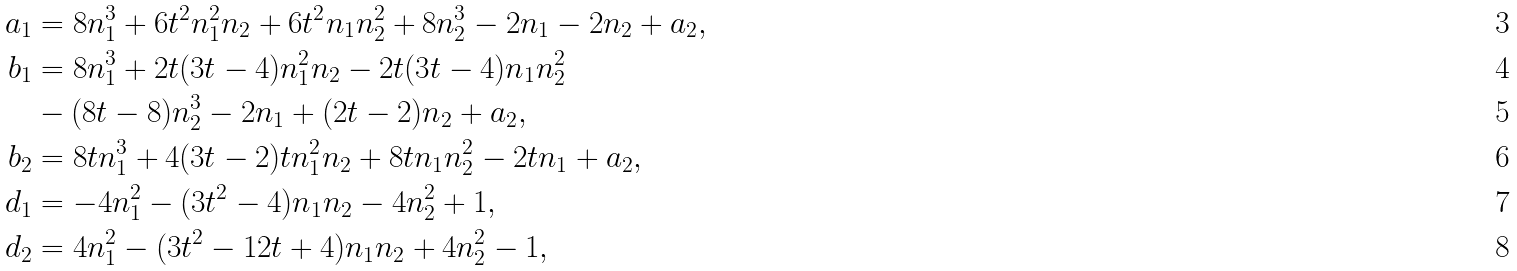Convert formula to latex. <formula><loc_0><loc_0><loc_500><loc_500>a _ { 1 } & = 8 n _ { 1 } ^ { 3 } + 6 t ^ { 2 } n _ { 1 } ^ { 2 } n _ { 2 } + 6 t ^ { 2 } n _ { 1 } n _ { 2 } ^ { 2 } + 8 n _ { 2 } ^ { 3 } - 2 n _ { 1 } - 2 n _ { 2 } + a _ { 2 } , \\ b _ { 1 } & = 8 n _ { 1 } ^ { 3 } + 2 t ( 3 t - 4 ) n _ { 1 } ^ { 2 } n _ { 2 } - 2 t ( 3 t - 4 ) n _ { 1 } n _ { 2 } ^ { 2 } \\ & - ( 8 t - 8 ) n _ { 2 } ^ { 3 } - 2 n _ { 1 } + ( 2 t - 2 ) n _ { 2 } + a _ { 2 } , \\ b _ { 2 } & = 8 t n _ { 1 } ^ { 3 } + 4 ( 3 t - 2 ) t n _ { 1 } ^ { 2 } n _ { 2 } + 8 t n _ { 1 } n _ { 2 } ^ { 2 } - 2 t n _ { 1 } + a _ { 2 } , \\ d _ { 1 } & = - 4 n _ { 1 } ^ { 2 } - ( 3 t ^ { 2 } - 4 ) n _ { 1 } n _ { 2 } - 4 n _ { 2 } ^ { 2 } + 1 , \\ d _ { 2 } & = 4 n _ { 1 } ^ { 2 } - ( 3 t ^ { 2 } - 1 2 t + 4 ) n _ { 1 } n _ { 2 } + 4 n _ { 2 } ^ { 2 } - 1 ,</formula> 